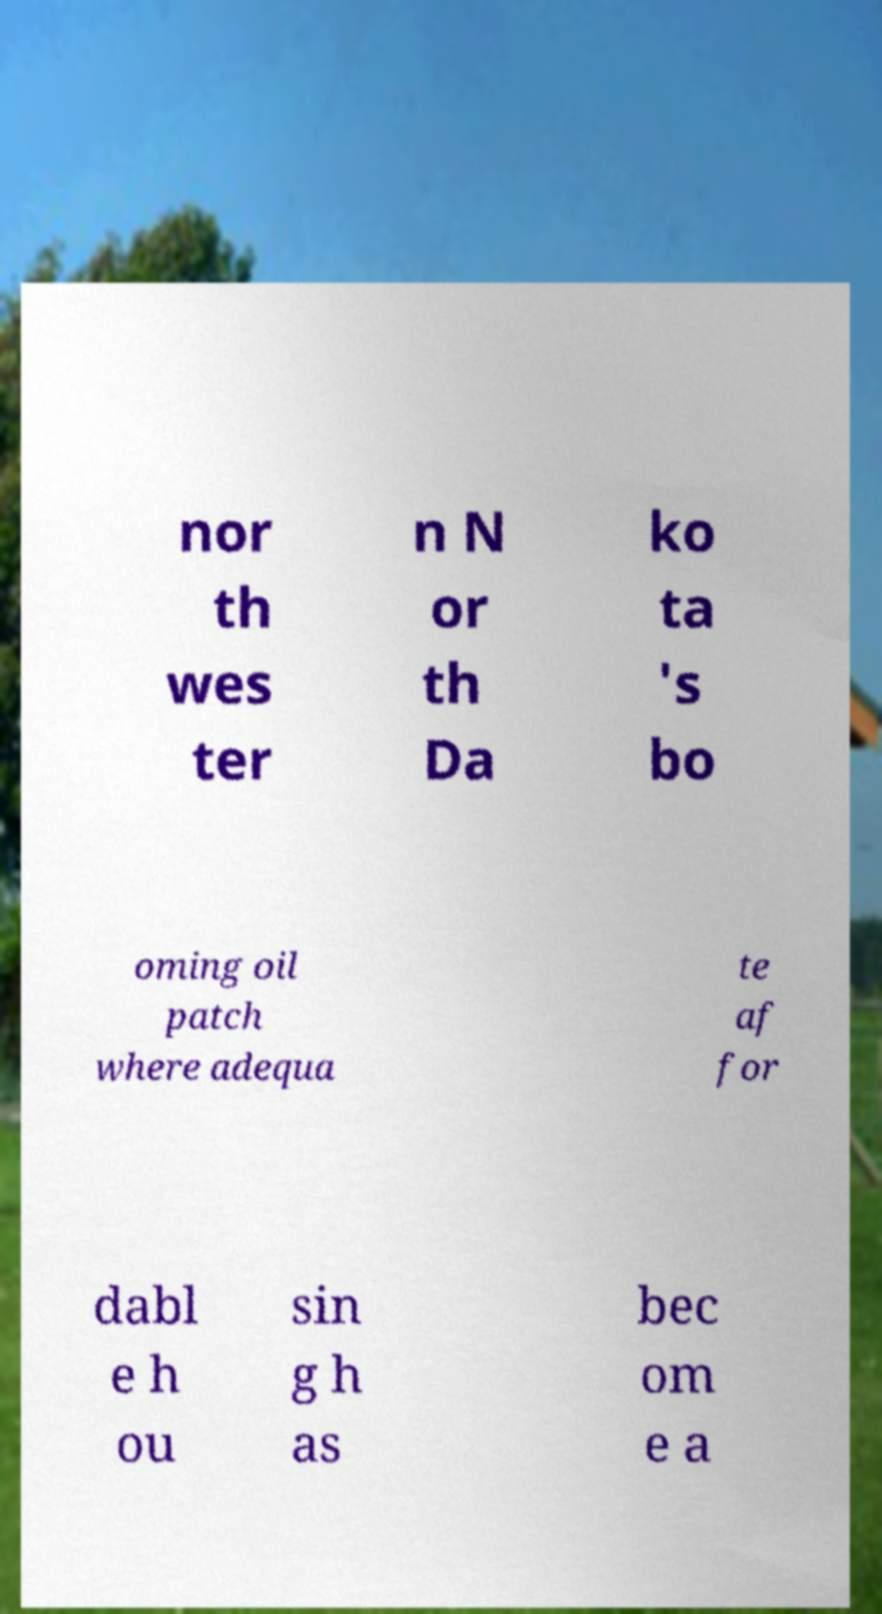Could you extract and type out the text from this image? nor th wes ter n N or th Da ko ta 's bo oming oil patch where adequa te af for dabl e h ou sin g h as bec om e a 